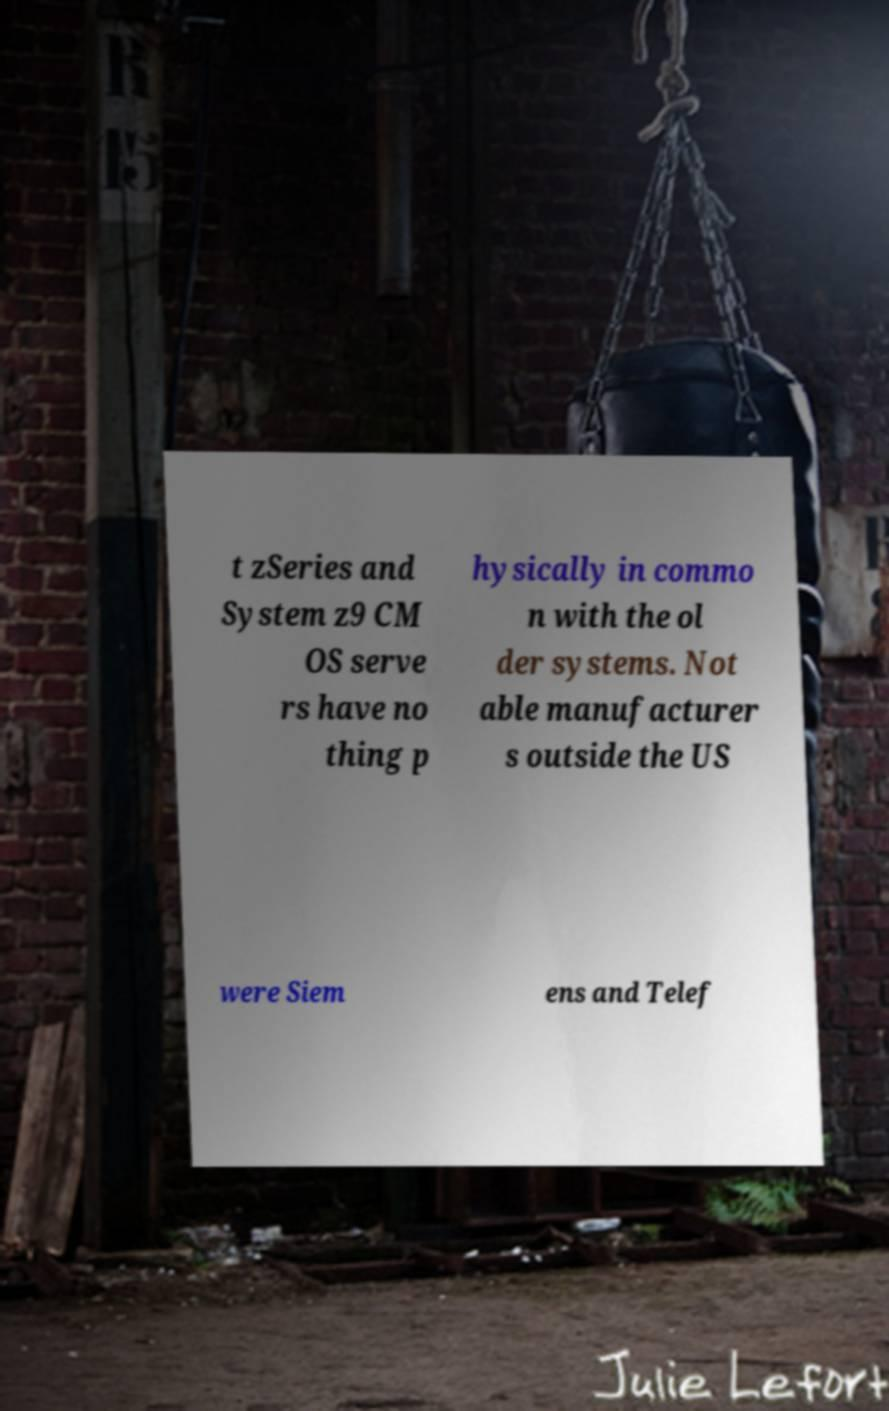Can you read and provide the text displayed in the image?This photo seems to have some interesting text. Can you extract and type it out for me? t zSeries and System z9 CM OS serve rs have no thing p hysically in commo n with the ol der systems. Not able manufacturer s outside the US were Siem ens and Telef 